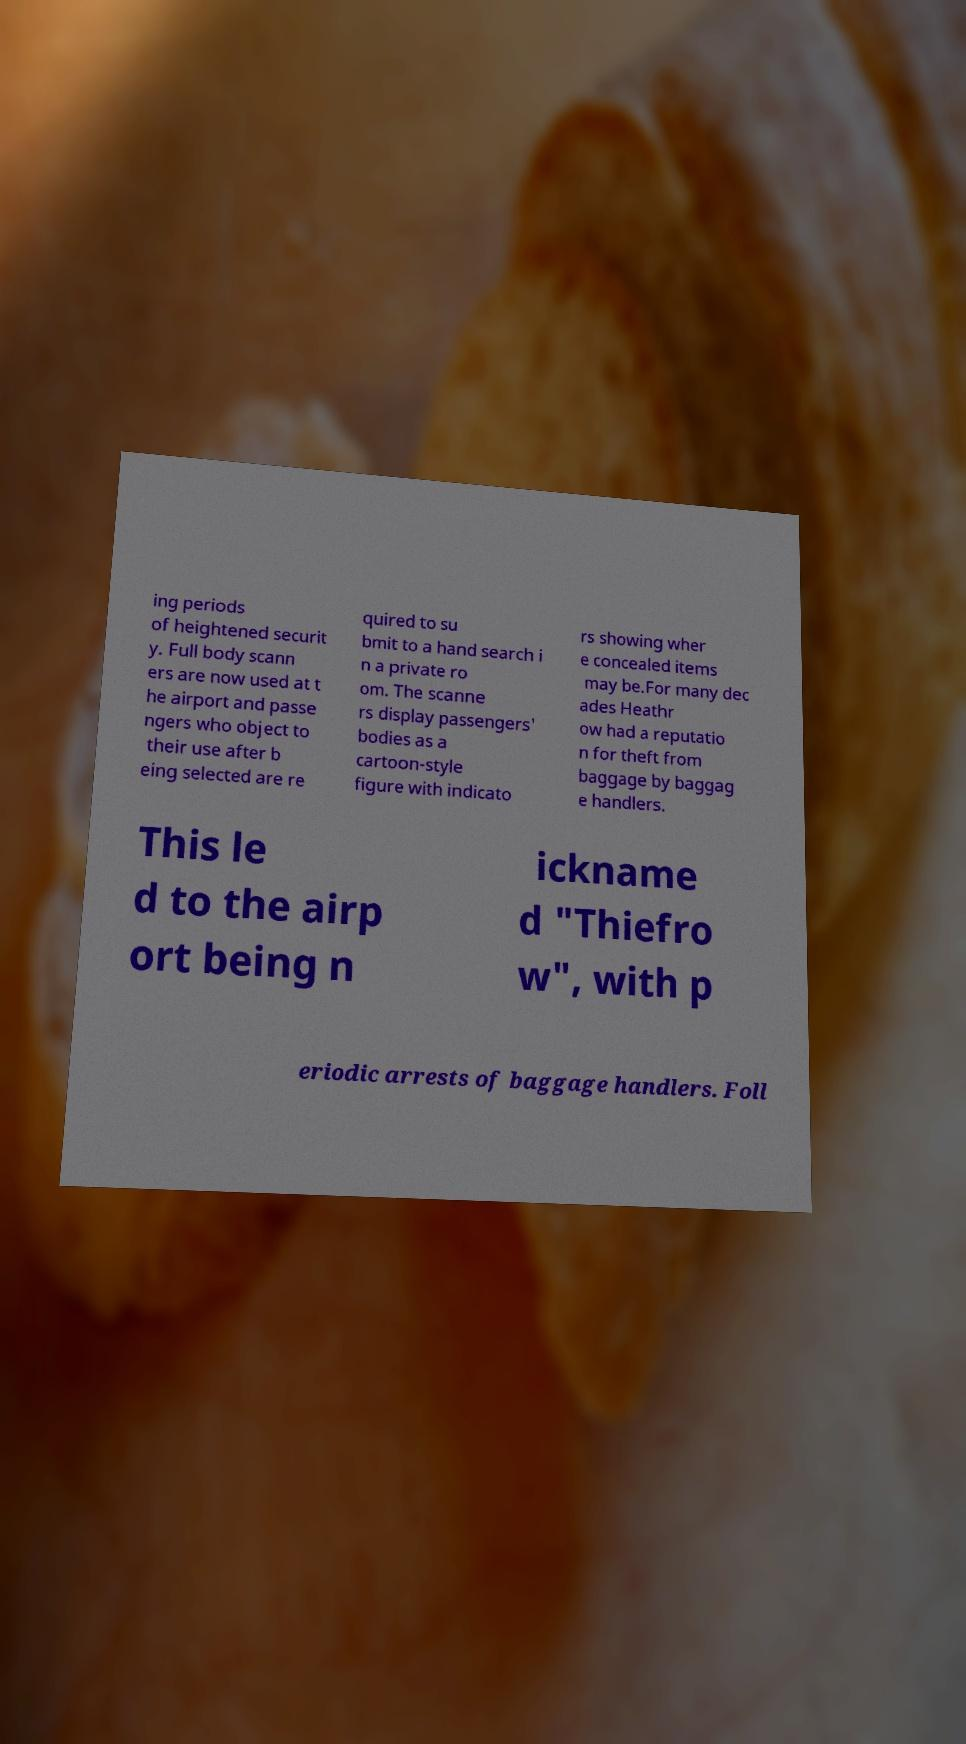What messages or text are displayed in this image? I need them in a readable, typed format. ing periods of heightened securit y. Full body scann ers are now used at t he airport and passe ngers who object to their use after b eing selected are re quired to su bmit to a hand search i n a private ro om. The scanne rs display passengers' bodies as a cartoon-style figure with indicato rs showing wher e concealed items may be.For many dec ades Heathr ow had a reputatio n for theft from baggage by baggag e handlers. This le d to the airp ort being n ickname d "Thiefro w", with p eriodic arrests of baggage handlers. Foll 